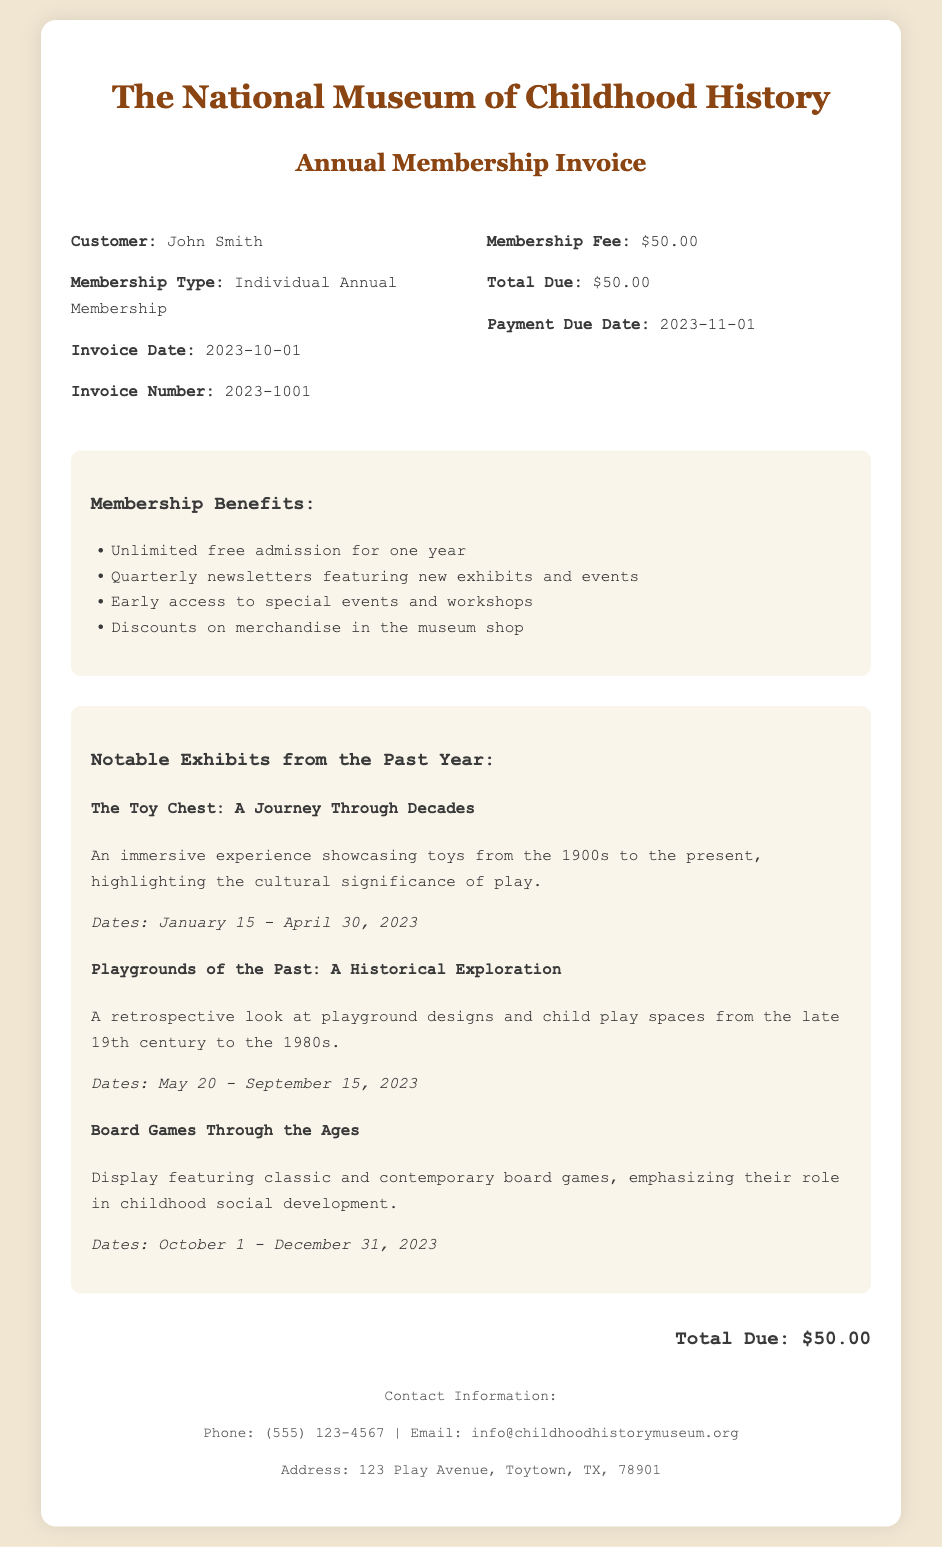What is the membership fee? The membership fee is explicitly stated in the invoice details section.
Answer: $50.00 When is the payment due date? The payment due date is listed in the invoice details section.
Answer: 2023-11-01 Who is the customer? The customer's name is provided in the invoice details section.
Answer: John Smith What is one benefit of the membership? The benefits of membership are clearly listed in the document.
Answer: Unlimited free admission for one year What is the title of the first notable exhibit? The title of the first notable exhibit is listed in the exhibits section.
Answer: The Toy Chest: A Journey Through Decades How long did the exhibit "Playgrounds of the Past" run? The duration of the exhibit is mentioned in the description of that exhibit.
Answer: May 20 - September 15, 2023 What is the total due amount? The total due is repeated in the invoice and also summarized at the bottom.
Answer: $50.00 How many exhibits are listed in the document? The number of exhibits can be counted from the exhibits section.
Answer: Three What type of membership is specified? The membership type is noted in the invoice details section.
Answer: Individual Annual Membership What emphasizes the cultural significance of play? The description of an exhibit provides this emphasis.
Answer: The Toy Chest: A Journey Through Decades 